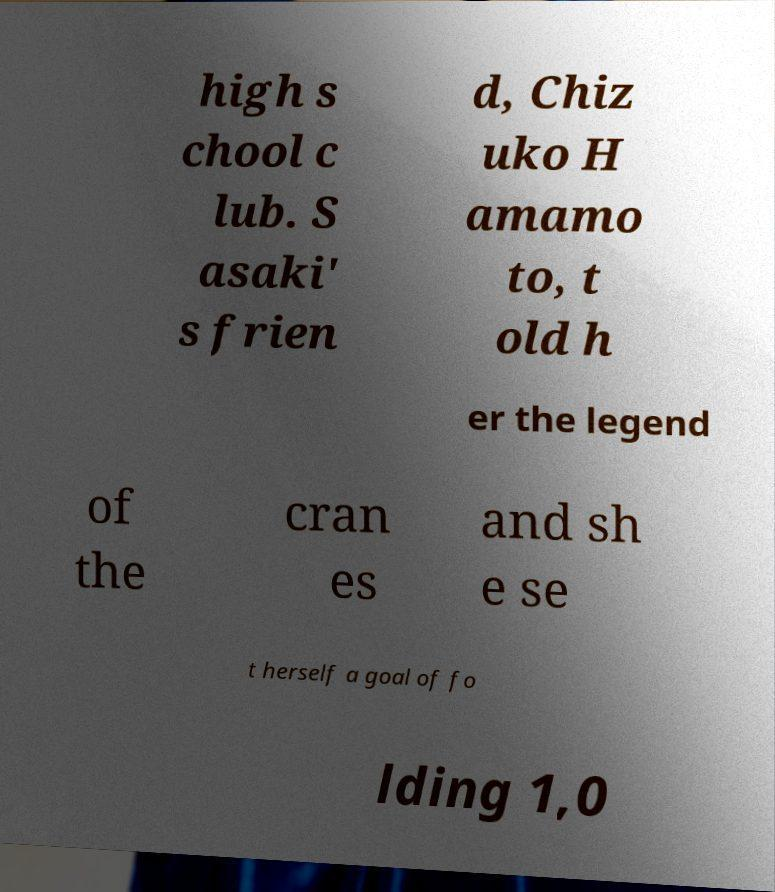Can you accurately transcribe the text from the provided image for me? high s chool c lub. S asaki' s frien d, Chiz uko H amamo to, t old h er the legend of the cran es and sh e se t herself a goal of fo lding 1,0 